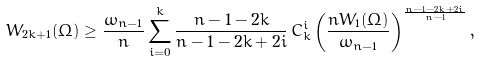<formula> <loc_0><loc_0><loc_500><loc_500>W _ { 2 k + 1 } ( \Omega ) \geq \frac { \omega _ { n - 1 } } { n } \sum _ { i = 0 } ^ { k } \frac { n - 1 - 2 k } { n - 1 - 2 k + 2 i } \, C _ { k } ^ { i } \left ( \frac { n W _ { 1 } ( \Omega ) } { \omega _ { n - 1 } } \right ) ^ { \frac { n - 1 - 2 k + 2 i } { n - 1 } } ,</formula> 